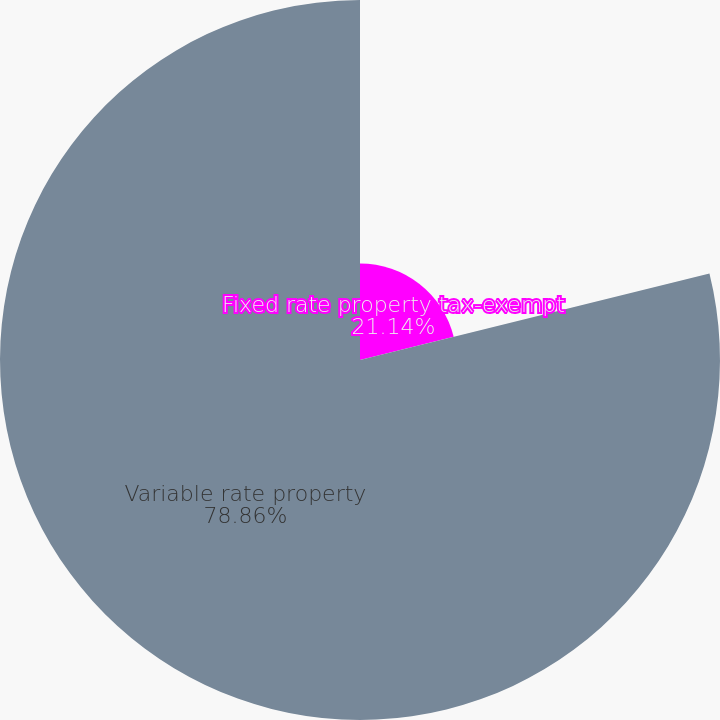Convert chart. <chart><loc_0><loc_0><loc_500><loc_500><pie_chart><fcel>Fixed rate property tax-exempt<fcel>Variable rate property<nl><fcel>21.14%<fcel>78.86%<nl></chart> 